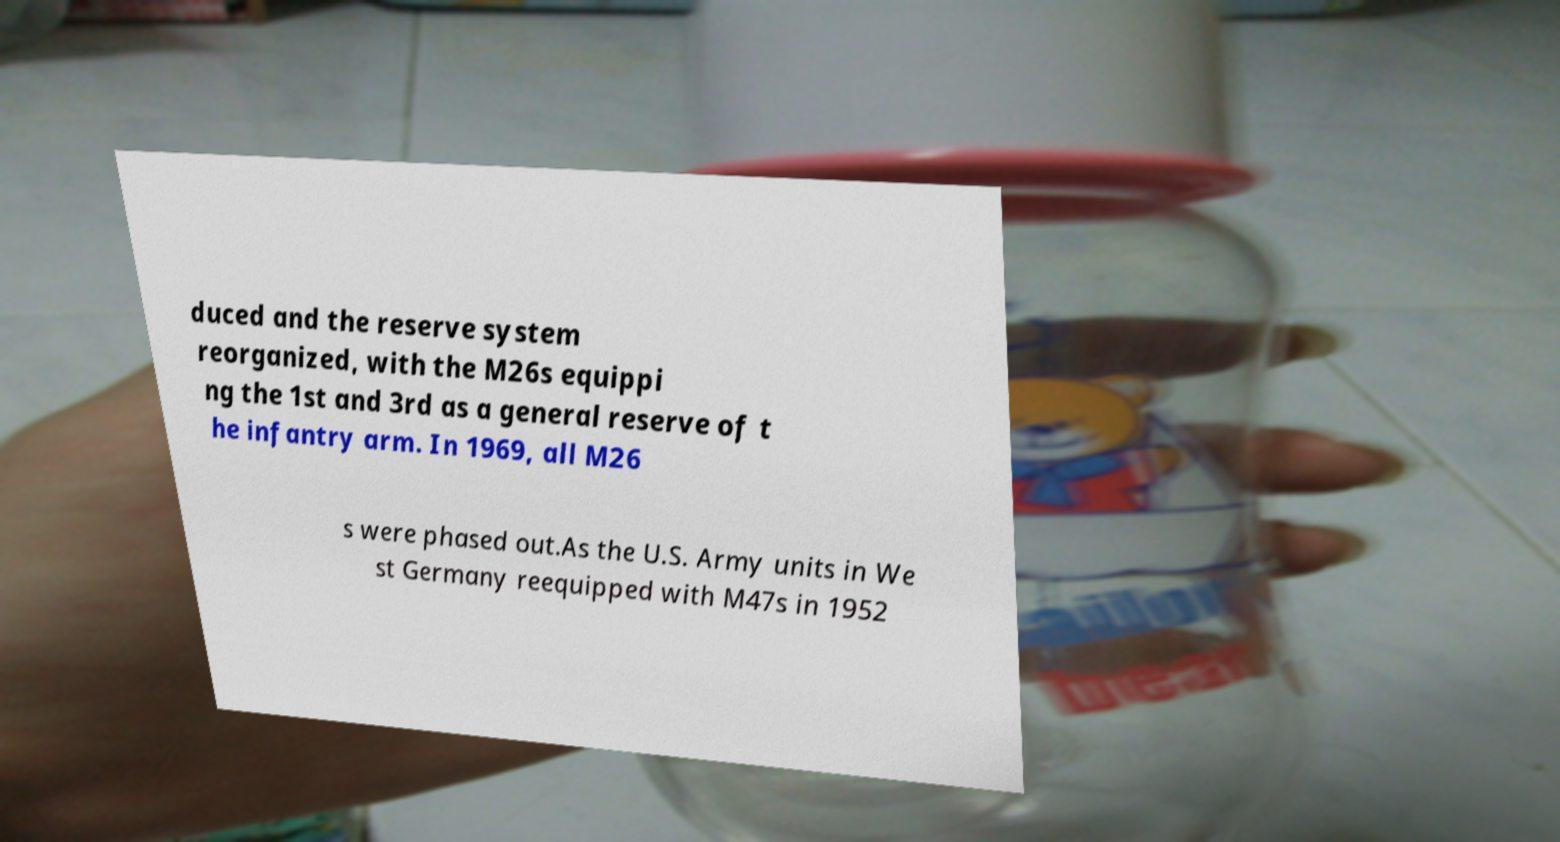Could you extract and type out the text from this image? duced and the reserve system reorganized, with the M26s equippi ng the 1st and 3rd as a general reserve of t he infantry arm. In 1969, all M26 s were phased out.As the U.S. Army units in We st Germany reequipped with M47s in 1952 